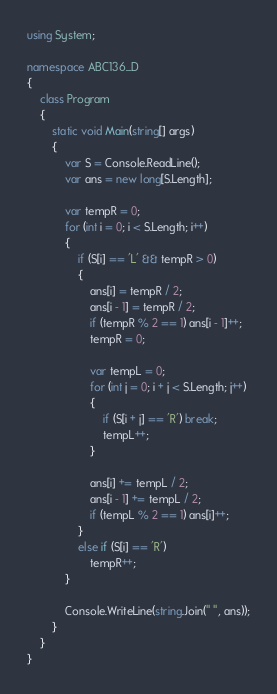<code> <loc_0><loc_0><loc_500><loc_500><_C#_>using System;

namespace ABC136_D
{
    class Program
    {
        static void Main(string[] args)
        {
            var S = Console.ReadLine();
            var ans = new long[S.Length];

            var tempR = 0;
            for (int i = 0; i < S.Length; i++)
            {
                if (S[i] == 'L' && tempR > 0)
                {
                    ans[i] = tempR / 2;
                    ans[i - 1] = tempR / 2;
                    if (tempR % 2 == 1) ans[i - 1]++;
                    tempR = 0;

                    var tempL = 0;
                    for (int j = 0; i + j < S.Length; j++)
                    {
                        if (S[i + j] == 'R') break;
                        tempL++;
                    }

                    ans[i] += tempL / 2;
                    ans[i - 1] += tempL / 2;
                    if (tempL % 2 == 1) ans[i]++;
                }
                else if (S[i] == 'R')
                    tempR++;
            }

            Console.WriteLine(string.Join(" ", ans));
        }
    }
}
</code> 